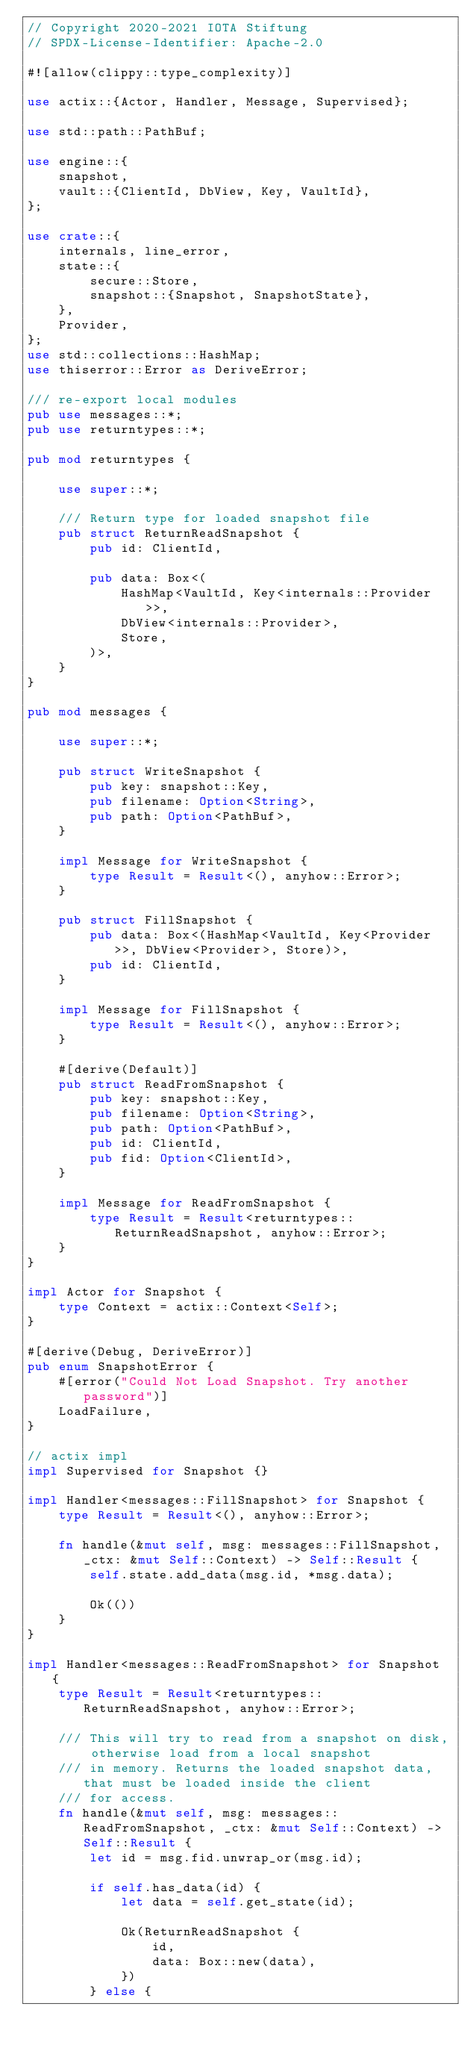Convert code to text. <code><loc_0><loc_0><loc_500><loc_500><_Rust_>// Copyright 2020-2021 IOTA Stiftung
// SPDX-License-Identifier: Apache-2.0

#![allow(clippy::type_complexity)]

use actix::{Actor, Handler, Message, Supervised};

use std::path::PathBuf;

use engine::{
    snapshot,
    vault::{ClientId, DbView, Key, VaultId},
};

use crate::{
    internals, line_error,
    state::{
        secure::Store,
        snapshot::{Snapshot, SnapshotState},
    },
    Provider,
};
use std::collections::HashMap;
use thiserror::Error as DeriveError;

/// re-export local modules
pub use messages::*;
pub use returntypes::*;

pub mod returntypes {

    use super::*;

    /// Return type for loaded snapshot file
    pub struct ReturnReadSnapshot {
        pub id: ClientId,

        pub data: Box<(
            HashMap<VaultId, Key<internals::Provider>>,
            DbView<internals::Provider>,
            Store,
        )>,
    }
}

pub mod messages {

    use super::*;

    pub struct WriteSnapshot {
        pub key: snapshot::Key,
        pub filename: Option<String>,
        pub path: Option<PathBuf>,
    }

    impl Message for WriteSnapshot {
        type Result = Result<(), anyhow::Error>;
    }

    pub struct FillSnapshot {
        pub data: Box<(HashMap<VaultId, Key<Provider>>, DbView<Provider>, Store)>,
        pub id: ClientId,
    }

    impl Message for FillSnapshot {
        type Result = Result<(), anyhow::Error>;
    }

    #[derive(Default)]
    pub struct ReadFromSnapshot {
        pub key: snapshot::Key,
        pub filename: Option<String>,
        pub path: Option<PathBuf>,
        pub id: ClientId,
        pub fid: Option<ClientId>,
    }

    impl Message for ReadFromSnapshot {
        type Result = Result<returntypes::ReturnReadSnapshot, anyhow::Error>;
    }
}

impl Actor for Snapshot {
    type Context = actix::Context<Self>;
}

#[derive(Debug, DeriveError)]
pub enum SnapshotError {
    #[error("Could Not Load Snapshot. Try another password")]
    LoadFailure,
}

// actix impl
impl Supervised for Snapshot {}

impl Handler<messages::FillSnapshot> for Snapshot {
    type Result = Result<(), anyhow::Error>;

    fn handle(&mut self, msg: messages::FillSnapshot, _ctx: &mut Self::Context) -> Self::Result {
        self.state.add_data(msg.id, *msg.data);

        Ok(())
    }
}

impl Handler<messages::ReadFromSnapshot> for Snapshot {
    type Result = Result<returntypes::ReturnReadSnapshot, anyhow::Error>;

    /// This will try to read from a snapshot on disk, otherwise load from a local snapshot
    /// in memory. Returns the loaded snapshot data, that must be loaded inside the client
    /// for access.
    fn handle(&mut self, msg: messages::ReadFromSnapshot, _ctx: &mut Self::Context) -> Self::Result {
        let id = msg.fid.unwrap_or(msg.id);

        if self.has_data(id) {
            let data = self.get_state(id);

            Ok(ReturnReadSnapshot {
                id,
                data: Box::new(data),
            })
        } else {</code> 